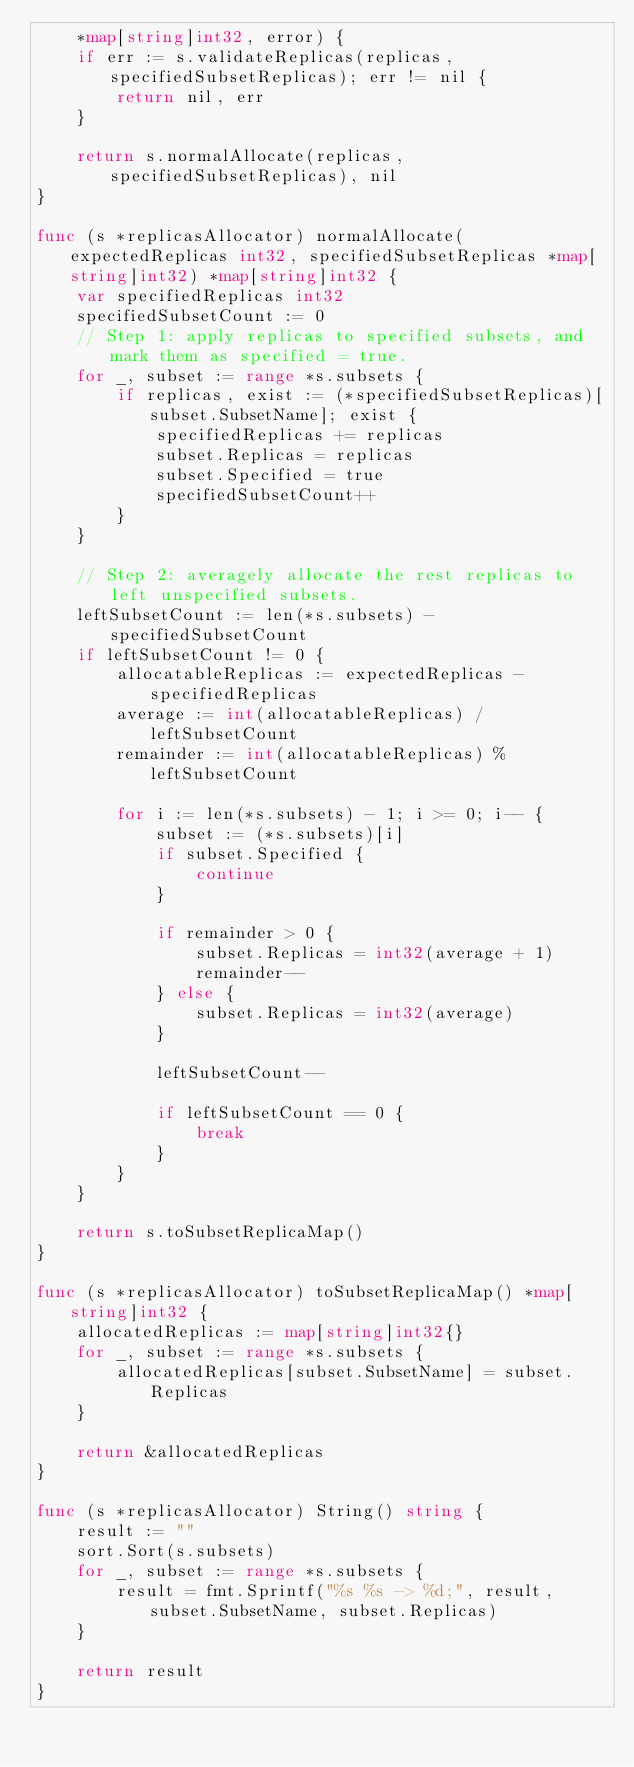Convert code to text. <code><loc_0><loc_0><loc_500><loc_500><_Go_>	*map[string]int32, error) {
	if err := s.validateReplicas(replicas, specifiedSubsetReplicas); err != nil {
		return nil, err
	}

	return s.normalAllocate(replicas, specifiedSubsetReplicas), nil
}

func (s *replicasAllocator) normalAllocate(expectedReplicas int32, specifiedSubsetReplicas *map[string]int32) *map[string]int32 {
	var specifiedReplicas int32
	specifiedSubsetCount := 0
	// Step 1: apply replicas to specified subsets, and mark them as specified = true.
	for _, subset := range *s.subsets {
		if replicas, exist := (*specifiedSubsetReplicas)[subset.SubsetName]; exist {
			specifiedReplicas += replicas
			subset.Replicas = replicas
			subset.Specified = true
			specifiedSubsetCount++
		}
	}

	// Step 2: averagely allocate the rest replicas to left unspecified subsets.
	leftSubsetCount := len(*s.subsets) - specifiedSubsetCount
	if leftSubsetCount != 0 {
		allocatableReplicas := expectedReplicas - specifiedReplicas
		average := int(allocatableReplicas) / leftSubsetCount
		remainder := int(allocatableReplicas) % leftSubsetCount

		for i := len(*s.subsets) - 1; i >= 0; i-- {
			subset := (*s.subsets)[i]
			if subset.Specified {
				continue
			}

			if remainder > 0 {
				subset.Replicas = int32(average + 1)
				remainder--
			} else {
				subset.Replicas = int32(average)
			}

			leftSubsetCount--

			if leftSubsetCount == 0 {
				break
			}
		}
	}

	return s.toSubsetReplicaMap()
}

func (s *replicasAllocator) toSubsetReplicaMap() *map[string]int32 {
	allocatedReplicas := map[string]int32{}
	for _, subset := range *s.subsets {
		allocatedReplicas[subset.SubsetName] = subset.Replicas
	}

	return &allocatedReplicas
}

func (s *replicasAllocator) String() string {
	result := ""
	sort.Sort(s.subsets)
	for _, subset := range *s.subsets {
		result = fmt.Sprintf("%s %s -> %d;", result, subset.SubsetName, subset.Replicas)
	}

	return result
}
</code> 